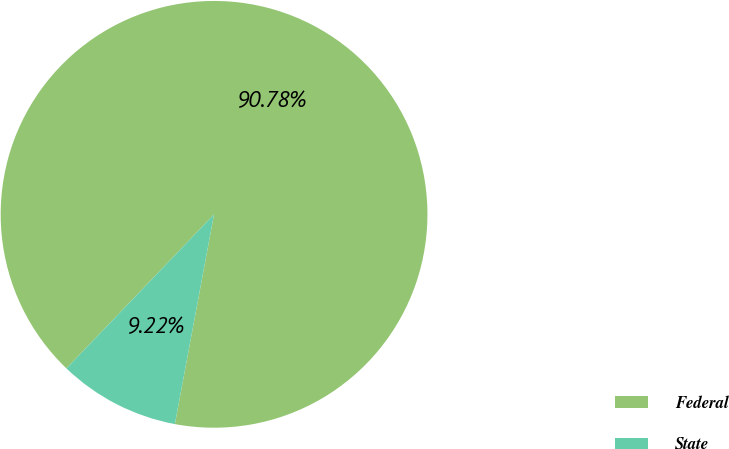Convert chart to OTSL. <chart><loc_0><loc_0><loc_500><loc_500><pie_chart><fcel>Federal<fcel>State<nl><fcel>90.78%<fcel>9.22%<nl></chart> 